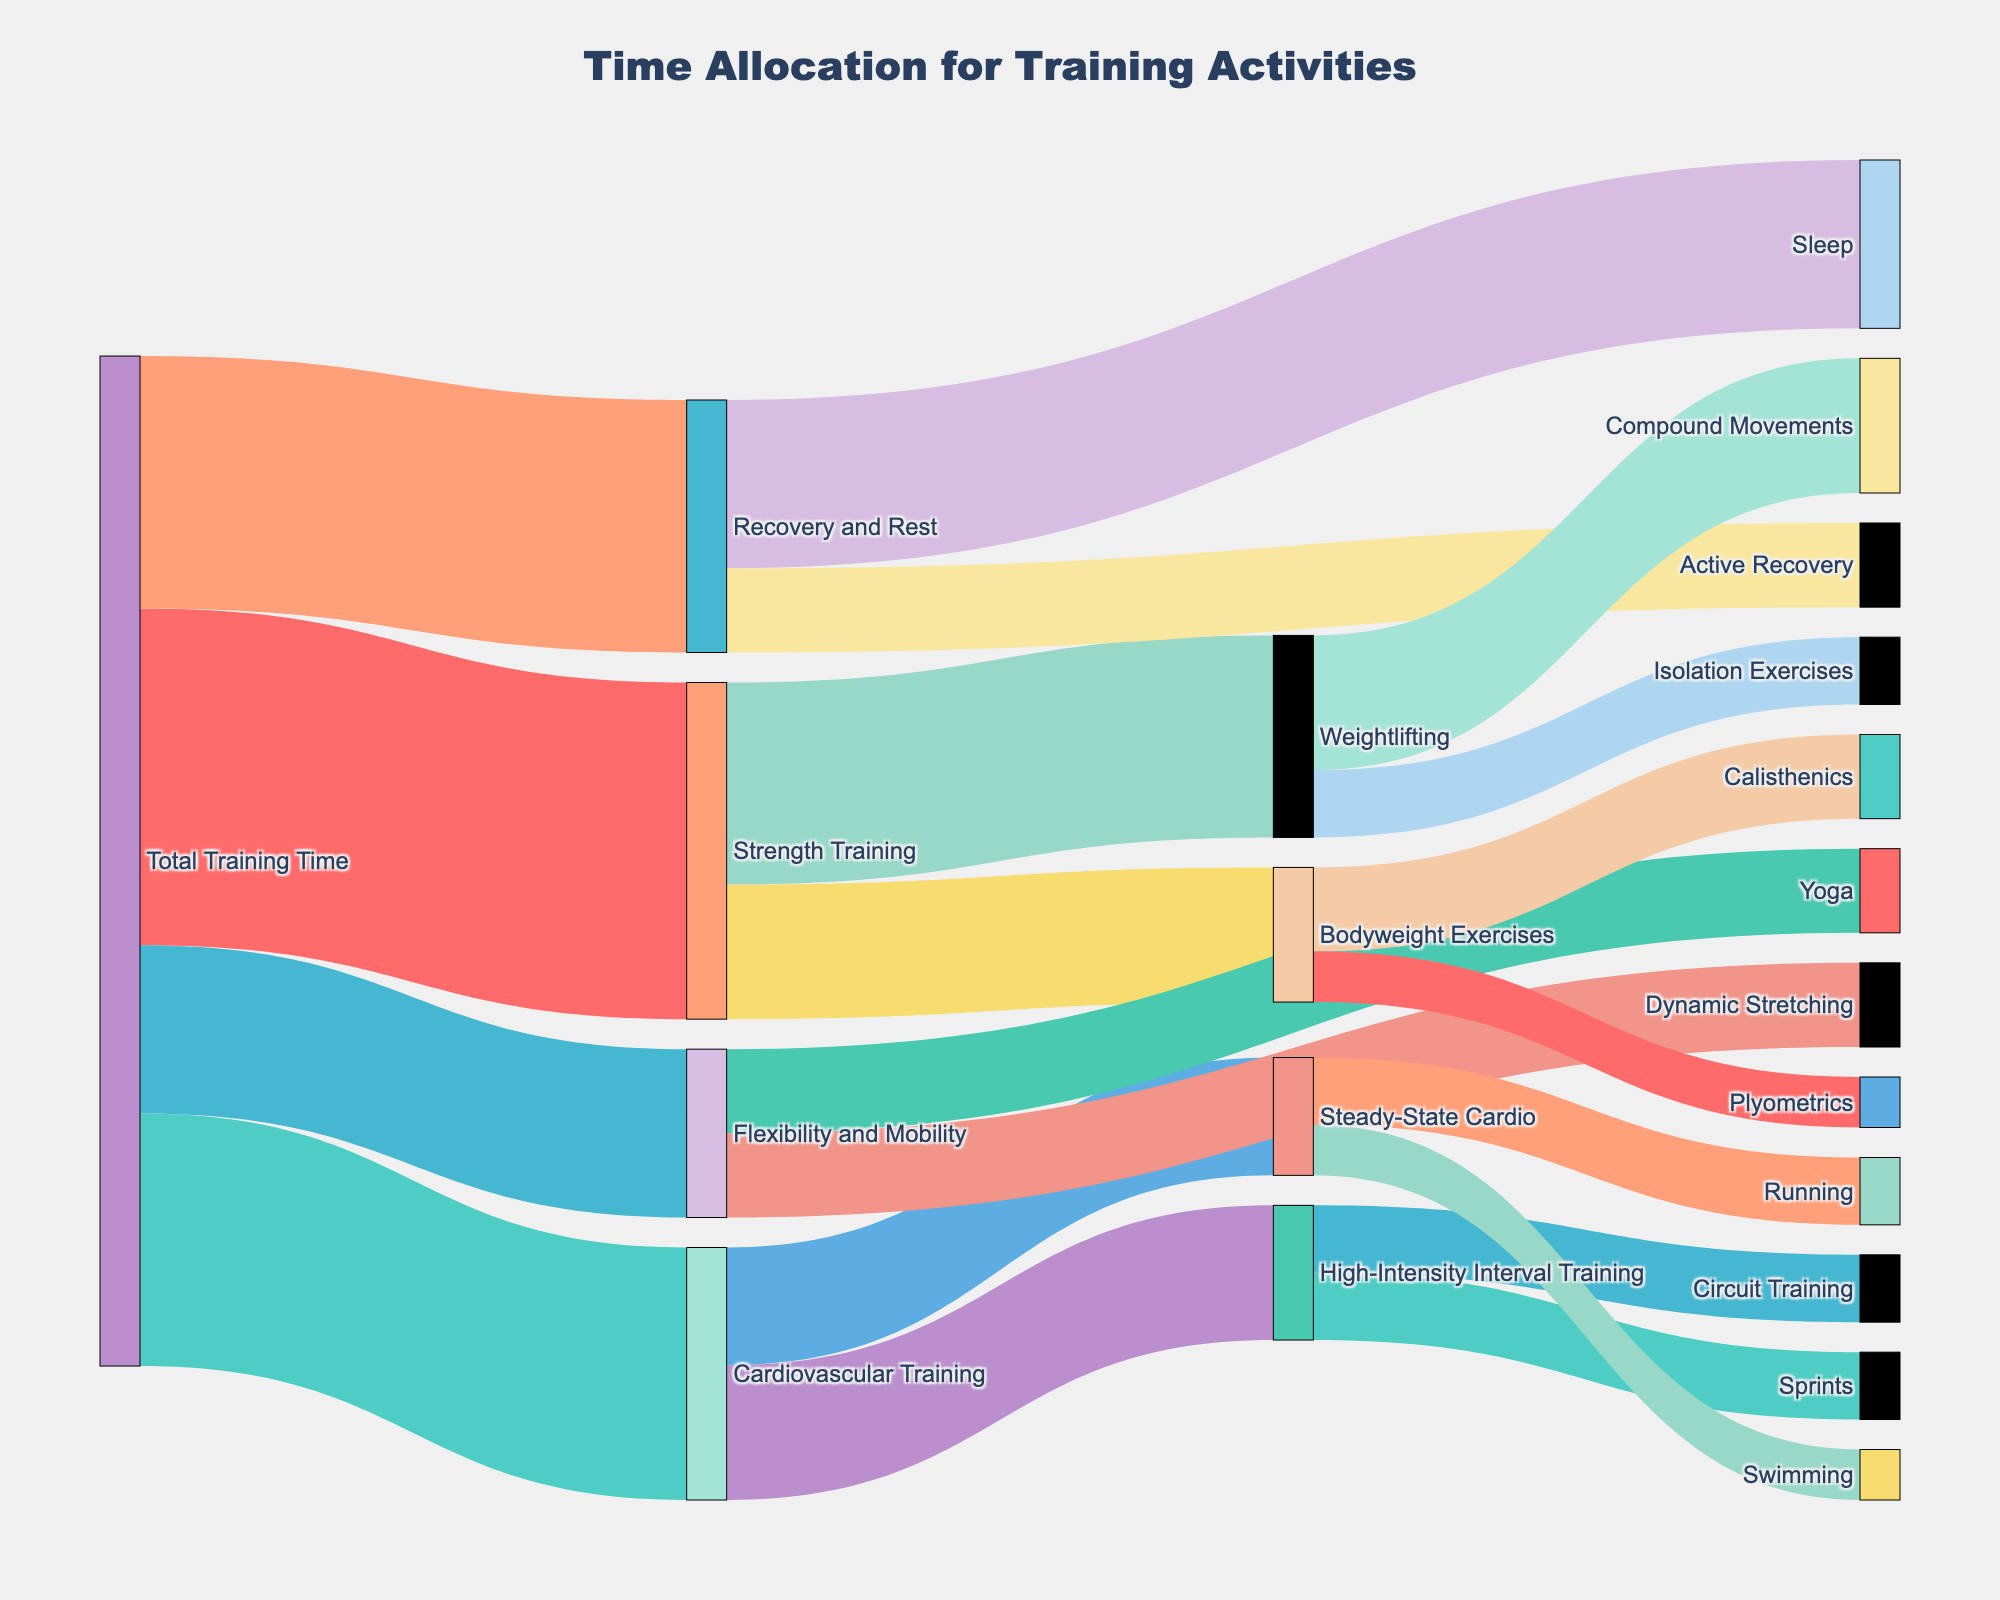what is the primary category for training time allocation? The primary category is represented by the largest rectangle starting from the leftmost side of the diagram. Here, it is labeled 'Total Training Time'.
Answer: Total Training Time What is the total time allocated to Strength Training? Follow the links originating from 'Total Training Time' to 'Strength Training'. The value at this connection shows the total time allocated to Strength Training.
Answer: 20 How much time is dedicated to Yoga out of Flexibility and Mobility training? Starting from the 'Flexibility and Mobility' node, trace the link that branches to 'Yoga'. The value at this connection represents the time dedicated to Yoga.
Answer: 5 What two categories make up the Recovery and Rest time allocation and how much time is allocated to each? Follow the links leaving 'Recovery and Rest' to identify the sub-categories. The values at these connections provide the time allocated to each.
Answer: Sleep (10), Active Recovery (5) Compare the time allocations for High-Intensity Interval Training and Steady-State Cardio within Cardiovascular Training. Follow the links from 'Cardiovascular Training' to 'High-Intensity Interval Training' and 'Steady-State Cardio'. Compare the values at these connections.
Answer: High-Intensity Interval Training (8) vs Steady-State Cardio (7) How many sub-categories are there under Strength Training and what are they? Follow the links originating from 'Strength Training' to identify the sub-categories. Count and list them.
Answer: Two sub-categories: Weightlifting and Bodyweight Exercises What is the ratio of time allocated to Steady-State Cardio's Running to Swimming? Trace the links from 'Steady-State Cardio' to 'Running' and 'Swimming'. Divide the time allocated to Running by the time allocated to Swimming.
Answer: 4:3 (Running: 4, Swimming: 3) Out of Bodyweight Exercises, how is the time split between Calisthenics and Plyometrics? Follow the links from 'Bodyweight Exercises' to 'Calisthenics' and 'Plyometrics'. The values at these connections determine the split.
Answer: Calisthenics (5), Plyometrics (3) Which training activity under Cardiovascular Training has equal time allocation to Bodyweight Exercises under Strength Training? Follow the links from 'Cardiovascular Training' and 'Strength Training' to find the value that matches 8, the time allocated to Bodyweight Exercises.
Answer: High-Intensity Interval Training 